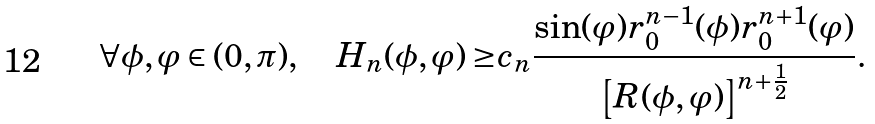<formula> <loc_0><loc_0><loc_500><loc_500>\forall \phi , \varphi \in ( 0 , \pi ) , \quad H _ { n } ( \phi , \varphi ) \geq & c _ { n } \frac { \sin ( \varphi ) r _ { 0 } ^ { n - 1 } ( \phi ) r _ { 0 } ^ { n + 1 } ( \varphi ) } { \left [ R ( \phi , \varphi ) \right ] ^ { n + \frac { 1 } { 2 } } } .</formula> 